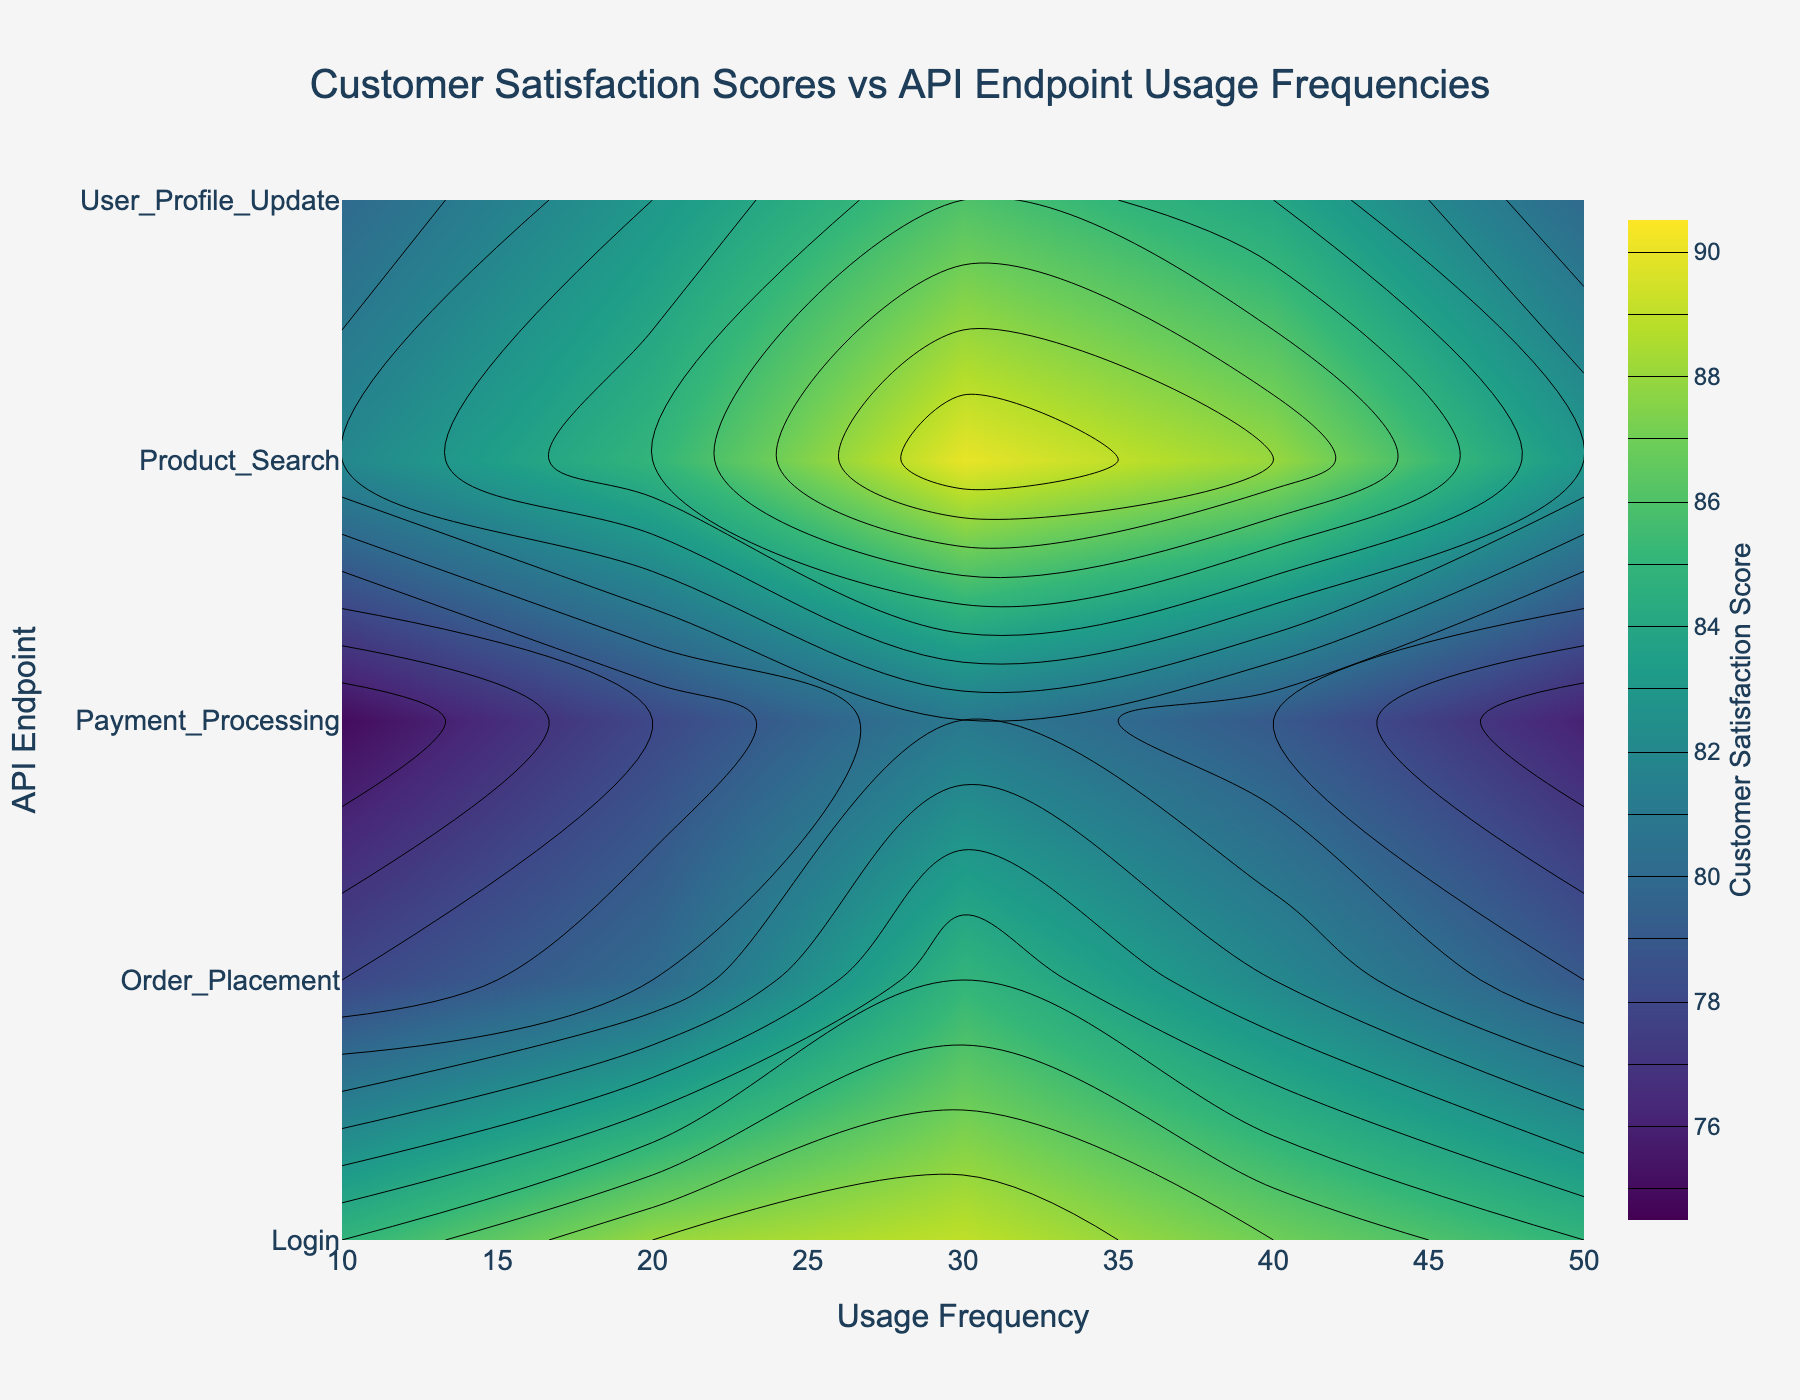What is the highest customer satisfaction score, and at what usage frequency and API endpoint does it occur? The highest score on the plot is 90. The position on the contour plot identifies the API endpoint as 'Product_Search' and the usage frequency as 30.
Answer: Product_Search at 30 Which API endpoint generally shows the lowest customer satisfaction scores across all usage frequencies? By observing the contour plot, Payment_Processing shows the lowest scores overall, with the lowest scores starting at 75.
Answer: Payment_Processing What is the average customer satisfaction score for the 'Login' API endpoint across all usage frequencies? Look at all the satisfaction scores for 'Login': (85 + 88 + 89 + 87 + 85). Their sum is 434, and the average is 434/5 = 86.8.
Answer: 86.8 Which API endpoint shows the most significant decrease in customer satisfaction when moving from low to high usage frequencies? Scan the contour plot to identify endpoints. For 'Login', it’s 85 to 85, which shows no change. Comparing the trends, 'Order_Placement' decreases from 85 to 79, 'Payment_Processing' from 81 to 76, and others have varying trends. 'Order_Placement' shows the sharpest steady drop.
Answer: Order_Placement Do any API endpoints maintain stable customer satisfaction scores regardless of usage frequency? 'Login' appears to have the most stable scores because the contour indicates minimal variation, holding around mid-to-high 80s.
Answer: Login How does customer satisfaction for 'Product_Search' compare at a usage frequency of 20 versus 50? The contour plot shows scores for 'Product_Search' as 85 at 20 uses and 83 at 50 uses. Comparing them shows higher satisfaction at 20.
Answer: Higher at 20 Which API endpoint has customer satisfaction scores peaking at 40 usage frequencies, and what is the score? Scan the contour plot at 40 for each endpoint. 'Product_Search' peaks at 88.
Answer: Product_Search with 88 What range of customer satisfaction scores does the contour plot depict? The color bar shows a range from 75 to 90 satisfaction scores.
Answer: 75 to 90 Which endpoint has a more consistent satisfaction score trend, 'User_Profile_Update' or 'Payment_Processing'? 'User_Profile_Update' moves between 80 to 86 with minor variations. 'Payment_Processing' ranges more widely from 75 to 81, showing less consistency.
Answer: User_Profile_Update 